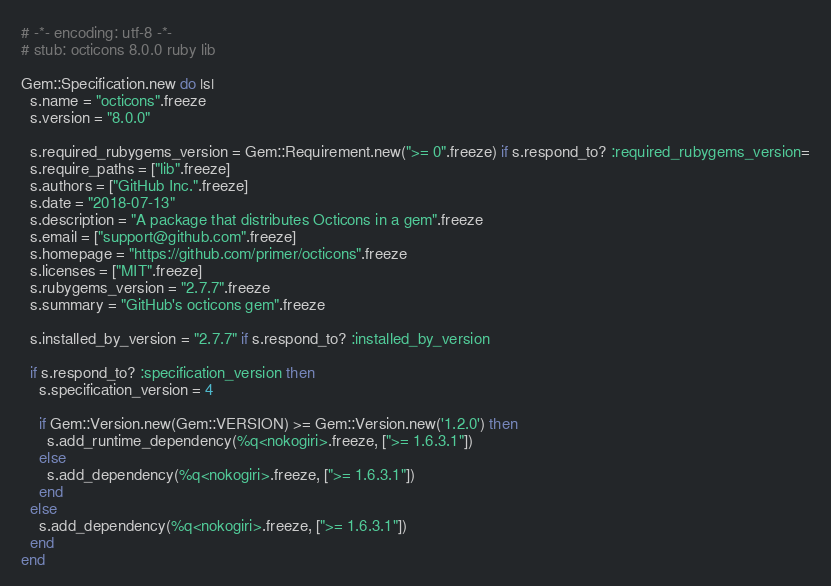<code> <loc_0><loc_0><loc_500><loc_500><_Ruby_># -*- encoding: utf-8 -*-
# stub: octicons 8.0.0 ruby lib

Gem::Specification.new do |s|
  s.name = "octicons".freeze
  s.version = "8.0.0"

  s.required_rubygems_version = Gem::Requirement.new(">= 0".freeze) if s.respond_to? :required_rubygems_version=
  s.require_paths = ["lib".freeze]
  s.authors = ["GitHub Inc.".freeze]
  s.date = "2018-07-13"
  s.description = "A package that distributes Octicons in a gem".freeze
  s.email = ["support@github.com".freeze]
  s.homepage = "https://github.com/primer/octicons".freeze
  s.licenses = ["MIT".freeze]
  s.rubygems_version = "2.7.7".freeze
  s.summary = "GitHub's octicons gem".freeze

  s.installed_by_version = "2.7.7" if s.respond_to? :installed_by_version

  if s.respond_to? :specification_version then
    s.specification_version = 4

    if Gem::Version.new(Gem::VERSION) >= Gem::Version.new('1.2.0') then
      s.add_runtime_dependency(%q<nokogiri>.freeze, [">= 1.6.3.1"])
    else
      s.add_dependency(%q<nokogiri>.freeze, [">= 1.6.3.1"])
    end
  else
    s.add_dependency(%q<nokogiri>.freeze, [">= 1.6.3.1"])
  end
end
</code> 